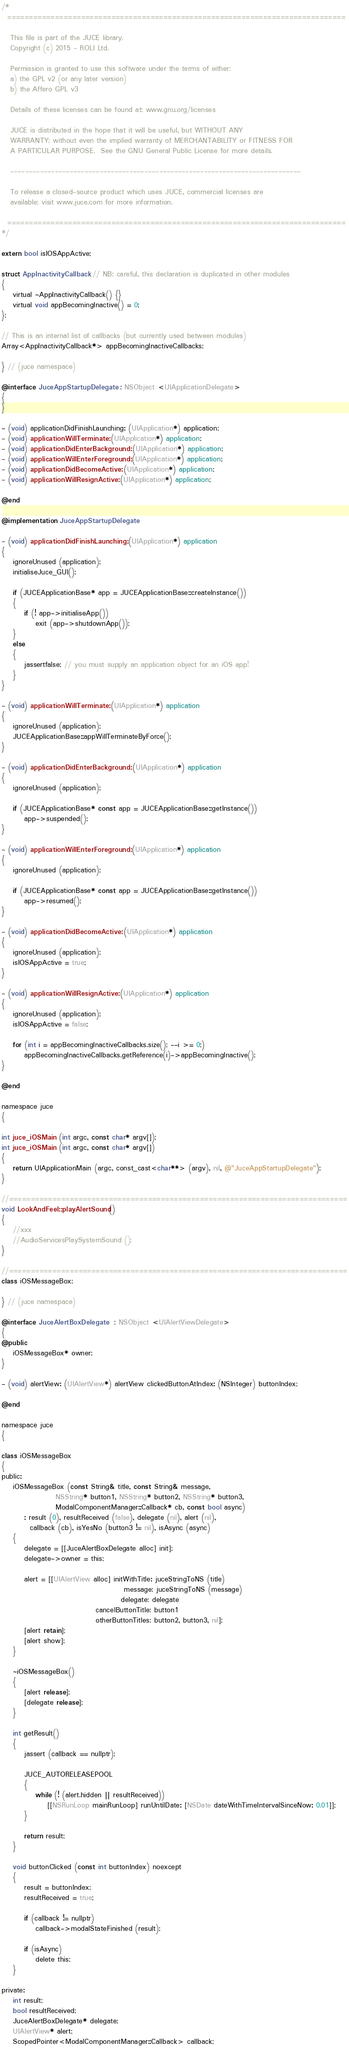<code> <loc_0><loc_0><loc_500><loc_500><_ObjectiveC_>/*
  ==============================================================================

   This file is part of the JUCE library.
   Copyright (c) 2015 - ROLI Ltd.

   Permission is granted to use this software under the terms of either:
   a) the GPL v2 (or any later version)
   b) the Affero GPL v3

   Details of these licenses can be found at: www.gnu.org/licenses

   JUCE is distributed in the hope that it will be useful, but WITHOUT ANY
   WARRANTY; without even the implied warranty of MERCHANTABILITY or FITNESS FOR
   A PARTICULAR PURPOSE.  See the GNU General Public License for more details.

   ------------------------------------------------------------------------------

   To release a closed-source product which uses JUCE, commercial licenses are
   available: visit www.juce.com for more information.

  ==============================================================================
*/

extern bool isIOSAppActive;

struct AppInactivityCallback // NB: careful, this declaration is duplicated in other modules
{
    virtual ~AppInactivityCallback() {}
    virtual void appBecomingInactive() = 0;
};

// This is an internal list of callbacks (but currently used between modules)
Array<AppInactivityCallback*> appBecomingInactiveCallbacks;

} // (juce namespace)

@interface JuceAppStartupDelegate : NSObject <UIApplicationDelegate>
{
}

- (void) applicationDidFinishLaunching: (UIApplication*) application;
- (void) applicationWillTerminate: (UIApplication*) application;
- (void) applicationDidEnterBackground: (UIApplication*) application;
- (void) applicationWillEnterForeground: (UIApplication*) application;
- (void) applicationDidBecomeActive: (UIApplication*) application;
- (void) applicationWillResignActive: (UIApplication*) application;

@end

@implementation JuceAppStartupDelegate

- (void) applicationDidFinishLaunching: (UIApplication*) application
{
    ignoreUnused (application);
    initialiseJuce_GUI();

    if (JUCEApplicationBase* app = JUCEApplicationBase::createInstance())
    {
        if (! app->initialiseApp())
            exit (app->shutdownApp());
    }
    else
    {
        jassertfalse; // you must supply an application object for an iOS app!
    }
}

- (void) applicationWillTerminate: (UIApplication*) application
{
    ignoreUnused (application);
    JUCEApplicationBase::appWillTerminateByForce();
}

- (void) applicationDidEnterBackground: (UIApplication*) application
{
    ignoreUnused (application);

    if (JUCEApplicationBase* const app = JUCEApplicationBase::getInstance())
        app->suspended();
}

- (void) applicationWillEnterForeground: (UIApplication*) application
{
    ignoreUnused (application);

    if (JUCEApplicationBase* const app = JUCEApplicationBase::getInstance())
        app->resumed();
}

- (void) applicationDidBecomeActive: (UIApplication*) application
{
    ignoreUnused (application);
    isIOSAppActive = true;
}

- (void) applicationWillResignActive: (UIApplication*) application
{
    ignoreUnused (application);
    isIOSAppActive = false;

    for (int i = appBecomingInactiveCallbacks.size(); --i >= 0;)
        appBecomingInactiveCallbacks.getReference(i)->appBecomingInactive();
}

@end

namespace juce
{

int juce_iOSMain (int argc, const char* argv[]);
int juce_iOSMain (int argc, const char* argv[])
{
    return UIApplicationMain (argc, const_cast<char**> (argv), nil, @"JuceAppStartupDelegate");
}

//==============================================================================
void LookAndFeel::playAlertSound()
{
    //xxx
    //AudioServicesPlaySystemSound ();
}

//==============================================================================
class iOSMessageBox;

} // (juce namespace)

@interface JuceAlertBoxDelegate  : NSObject <UIAlertViewDelegate>
{
@public
    iOSMessageBox* owner;
}

- (void) alertView: (UIAlertView*) alertView clickedButtonAtIndex: (NSInteger) buttonIndex;

@end

namespace juce
{

class iOSMessageBox
{
public:
    iOSMessageBox (const String& title, const String& message,
                   NSString* button1, NSString* button2, NSString* button3,
                   ModalComponentManager::Callback* cb, const bool async)
        : result (0), resultReceived (false), delegate (nil), alert (nil),
          callback (cb), isYesNo (button3 != nil), isAsync (async)
    {
        delegate = [[JuceAlertBoxDelegate alloc] init];
        delegate->owner = this;

        alert = [[UIAlertView alloc] initWithTitle: juceStringToNS (title)
                                           message: juceStringToNS (message)
                                          delegate: delegate
                                 cancelButtonTitle: button1
                                 otherButtonTitles: button2, button3, nil];
        [alert retain];
        [alert show];
    }

    ~iOSMessageBox()
    {
        [alert release];
        [delegate release];
    }

    int getResult()
    {
        jassert (callback == nullptr);

        JUCE_AUTORELEASEPOOL
        {
            while (! (alert.hidden || resultReceived))
                [[NSRunLoop mainRunLoop] runUntilDate: [NSDate dateWithTimeIntervalSinceNow: 0.01]];
        }

        return result;
    }

    void buttonClicked (const int buttonIndex) noexcept
    {
        result = buttonIndex;
        resultReceived = true;

        if (callback != nullptr)
            callback->modalStateFinished (result);

        if (isAsync)
            delete this;
    }

private:
    int result;
    bool resultReceived;
    JuceAlertBoxDelegate* delegate;
    UIAlertView* alert;
    ScopedPointer<ModalComponentManager::Callback> callback;</code> 